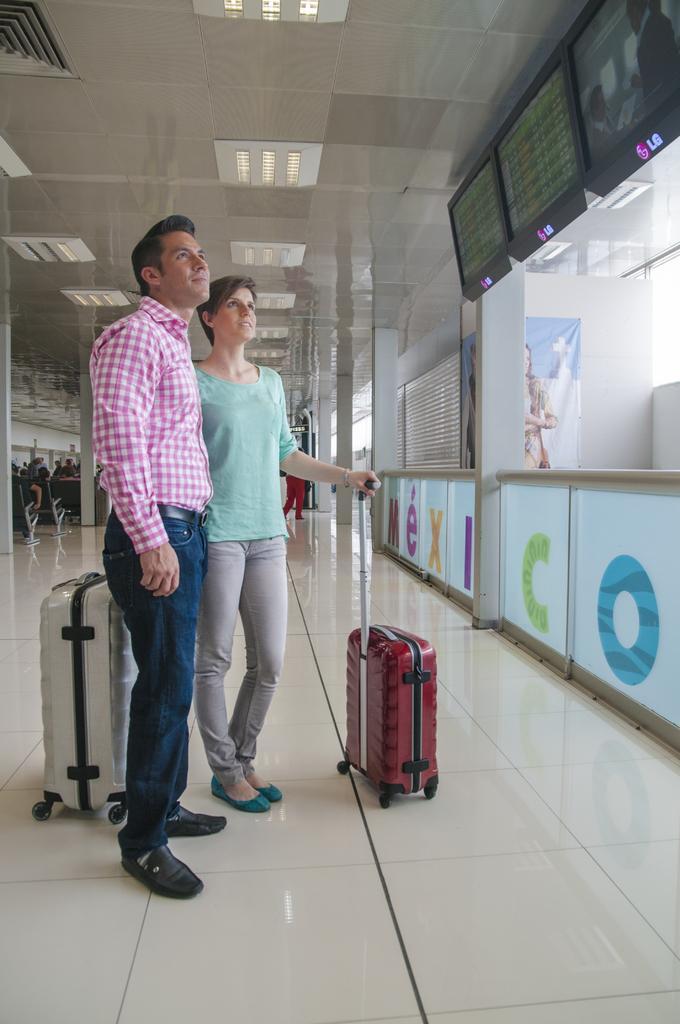In one or two sentences, can you explain what this image depicts? In this image i can see a man wearing a pink shirt and blue jeans and a woman wearing a green top are standing and holding the suitcases. In the background i can see the ceiling, an ac vent, few lights, few television screens,and few chairs,. 